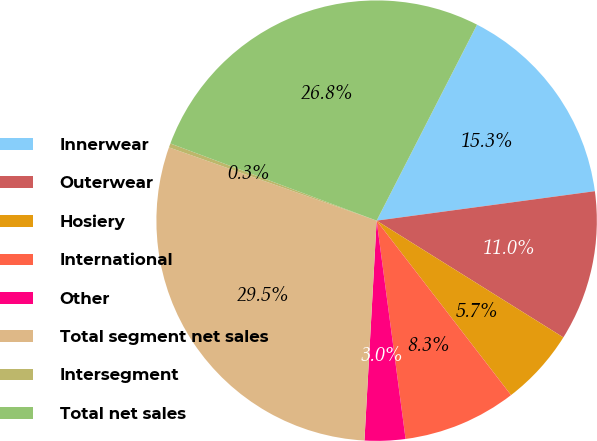Convert chart. <chart><loc_0><loc_0><loc_500><loc_500><pie_chart><fcel>Innerwear<fcel>Outerwear<fcel>Hosiery<fcel>International<fcel>Other<fcel>Total segment net sales<fcel>Intersegment<fcel>Total net sales<nl><fcel>15.33%<fcel>11.03%<fcel>5.66%<fcel>8.35%<fcel>2.98%<fcel>29.52%<fcel>0.3%<fcel>26.84%<nl></chart> 